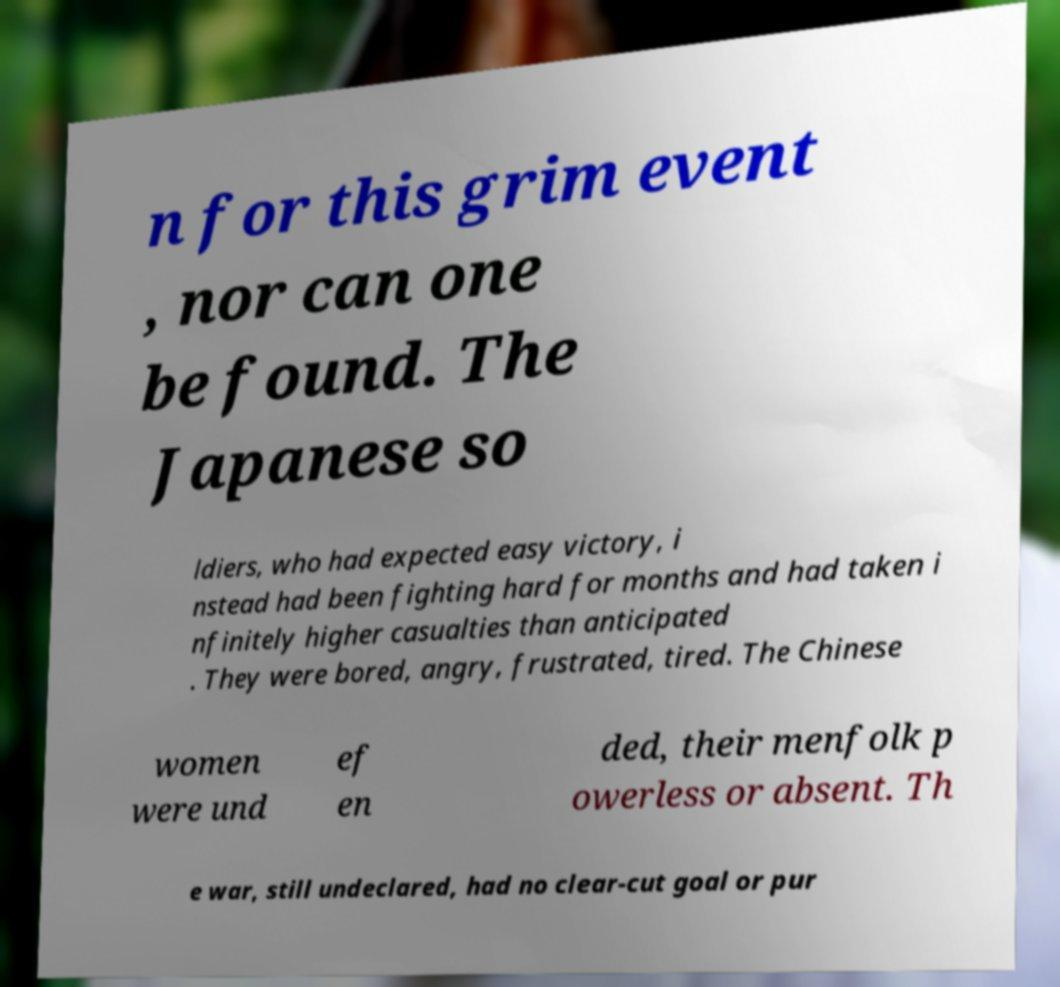Could you assist in decoding the text presented in this image and type it out clearly? n for this grim event , nor can one be found. The Japanese so ldiers, who had expected easy victory, i nstead had been fighting hard for months and had taken i nfinitely higher casualties than anticipated . They were bored, angry, frustrated, tired. The Chinese women were und ef en ded, their menfolk p owerless or absent. Th e war, still undeclared, had no clear-cut goal or pur 